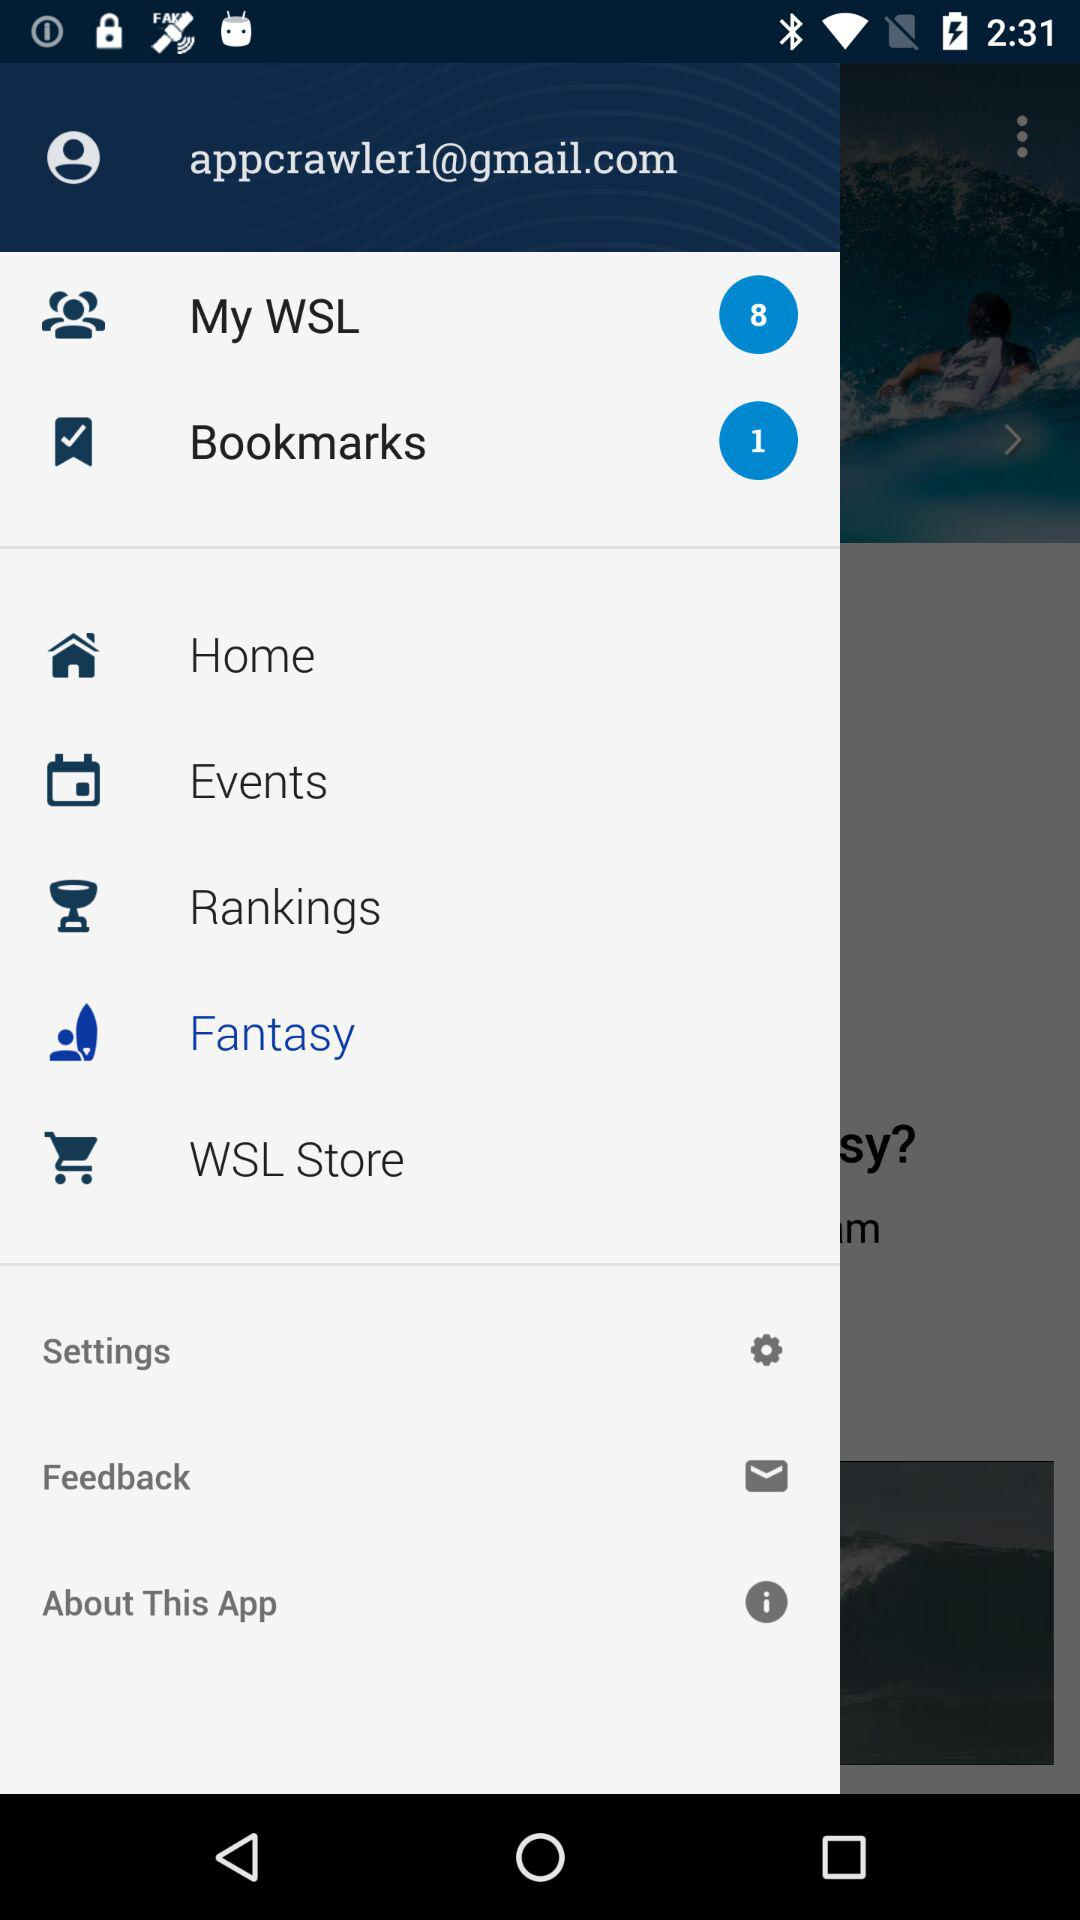What is the count of "My WSL"? The count of "My WSL" is 8. 